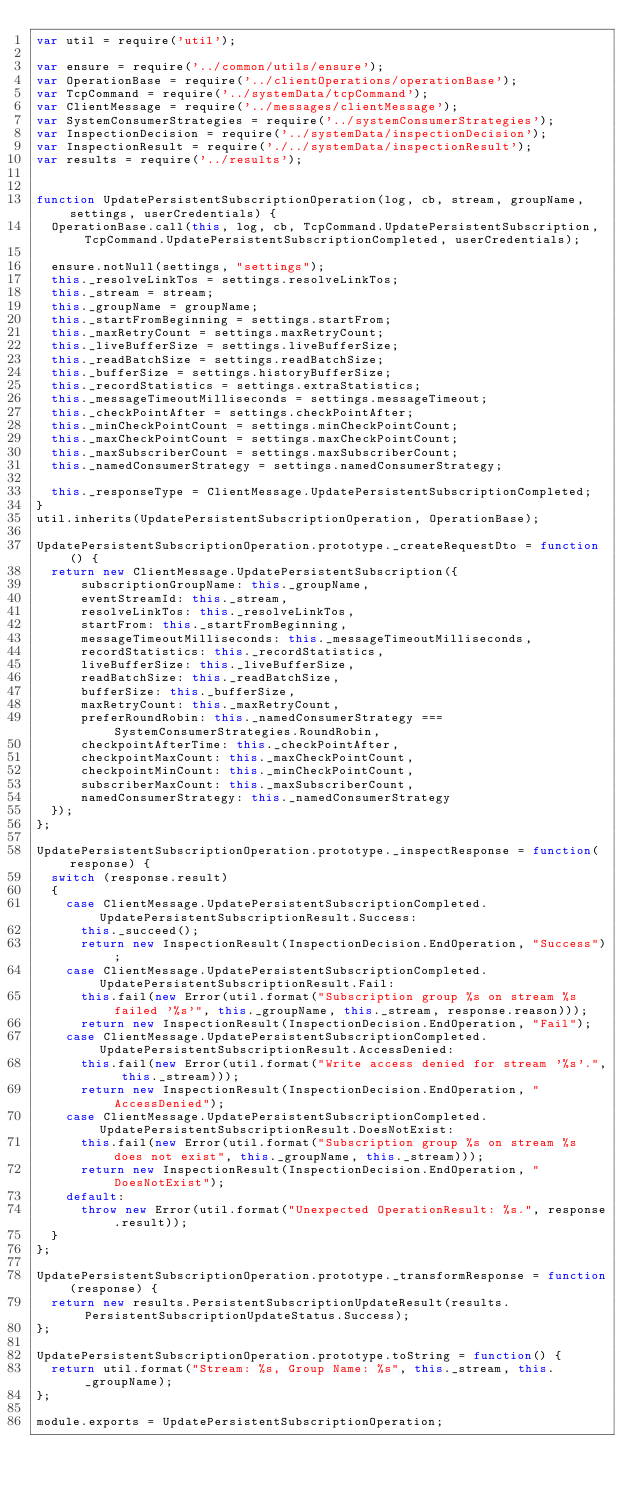Convert code to text. <code><loc_0><loc_0><loc_500><loc_500><_JavaScript_>var util = require('util');

var ensure = require('../common/utils/ensure');
var OperationBase = require('../clientOperations/operationBase');
var TcpCommand = require('../systemData/tcpCommand');
var ClientMessage = require('../messages/clientMessage');
var SystemConsumerStrategies = require('../systemConsumerStrategies');
var InspectionDecision = require('../systemData/inspectionDecision');
var InspectionResult = require('./../systemData/inspectionResult');
var results = require('../results');


function UpdatePersistentSubscriptionOperation(log, cb, stream, groupName, settings, userCredentials) {
  OperationBase.call(this, log, cb, TcpCommand.UpdatePersistentSubscription, TcpCommand.UpdatePersistentSubscriptionCompleted, userCredentials);

  ensure.notNull(settings, "settings");
  this._resolveLinkTos = settings.resolveLinkTos;
  this._stream = stream;
  this._groupName = groupName;
  this._startFromBeginning = settings.startFrom;
  this._maxRetryCount = settings.maxRetryCount;
  this._liveBufferSize = settings.liveBufferSize;
  this._readBatchSize = settings.readBatchSize;
  this._bufferSize = settings.historyBufferSize;
  this._recordStatistics = settings.extraStatistics;
  this._messageTimeoutMilliseconds = settings.messageTimeout;
  this._checkPointAfter = settings.checkPointAfter;
  this._minCheckPointCount = settings.minCheckPointCount;
  this._maxCheckPointCount = settings.maxCheckPointCount;
  this._maxSubscriberCount = settings.maxSubscriberCount;
  this._namedConsumerStrategy = settings.namedConsumerStrategy;

  this._responseType = ClientMessage.UpdatePersistentSubscriptionCompleted;
}
util.inherits(UpdatePersistentSubscriptionOperation, OperationBase);

UpdatePersistentSubscriptionOperation.prototype._createRequestDto = function() {
  return new ClientMessage.UpdatePersistentSubscription({
      subscriptionGroupName: this._groupName,
      eventStreamId: this._stream,
      resolveLinkTos: this._resolveLinkTos,
      startFrom: this._startFromBeginning,
      messageTimeoutMilliseconds: this._messageTimeoutMilliseconds,
      recordStatistics: this._recordStatistics,
      liveBufferSize: this._liveBufferSize,
      readBatchSize: this._readBatchSize,
      bufferSize: this._bufferSize,
      maxRetryCount: this._maxRetryCount,
      preferRoundRobin: this._namedConsumerStrategy === SystemConsumerStrategies.RoundRobin,
      checkpointAfterTime: this._checkPointAfter,
      checkpointMaxCount: this._maxCheckPointCount,
      checkpointMinCount: this._minCheckPointCount,
      subscriberMaxCount: this._maxSubscriberCount,
      namedConsumerStrategy: this._namedConsumerStrategy
  });
};

UpdatePersistentSubscriptionOperation.prototype._inspectResponse = function(response) {
  switch (response.result)
  {
    case ClientMessage.UpdatePersistentSubscriptionCompleted.UpdatePersistentSubscriptionResult.Success:
      this._succeed();
      return new InspectionResult(InspectionDecision.EndOperation, "Success");
    case ClientMessage.UpdatePersistentSubscriptionCompleted.UpdatePersistentSubscriptionResult.Fail:
      this.fail(new Error(util.format("Subscription group %s on stream %s failed '%s'", this._groupName, this._stream, response.reason)));
      return new InspectionResult(InspectionDecision.EndOperation, "Fail");
    case ClientMessage.UpdatePersistentSubscriptionCompleted.UpdatePersistentSubscriptionResult.AccessDenied:
      this.fail(new Error(util.format("Write access denied for stream '%s'.", this._stream)));
      return new InspectionResult(InspectionDecision.EndOperation, "AccessDenied");
    case ClientMessage.UpdatePersistentSubscriptionCompleted.UpdatePersistentSubscriptionResult.DoesNotExist:
      this.fail(new Error(util.format("Subscription group %s on stream %s does not exist", this._groupName, this._stream)));
      return new InspectionResult(InspectionDecision.EndOperation, "DoesNotExist");
    default:
      throw new Error(util.format("Unexpected OperationResult: %s.", response.result));
  }
};

UpdatePersistentSubscriptionOperation.prototype._transformResponse = function(response) {
  return new results.PersistentSubscriptionUpdateResult(results.PersistentSubscriptionUpdateStatus.Success);
};

UpdatePersistentSubscriptionOperation.prototype.toString = function() {
  return util.format("Stream: %s, Group Name: %s", this._stream, this._groupName);
};

module.exports = UpdatePersistentSubscriptionOperation;</code> 